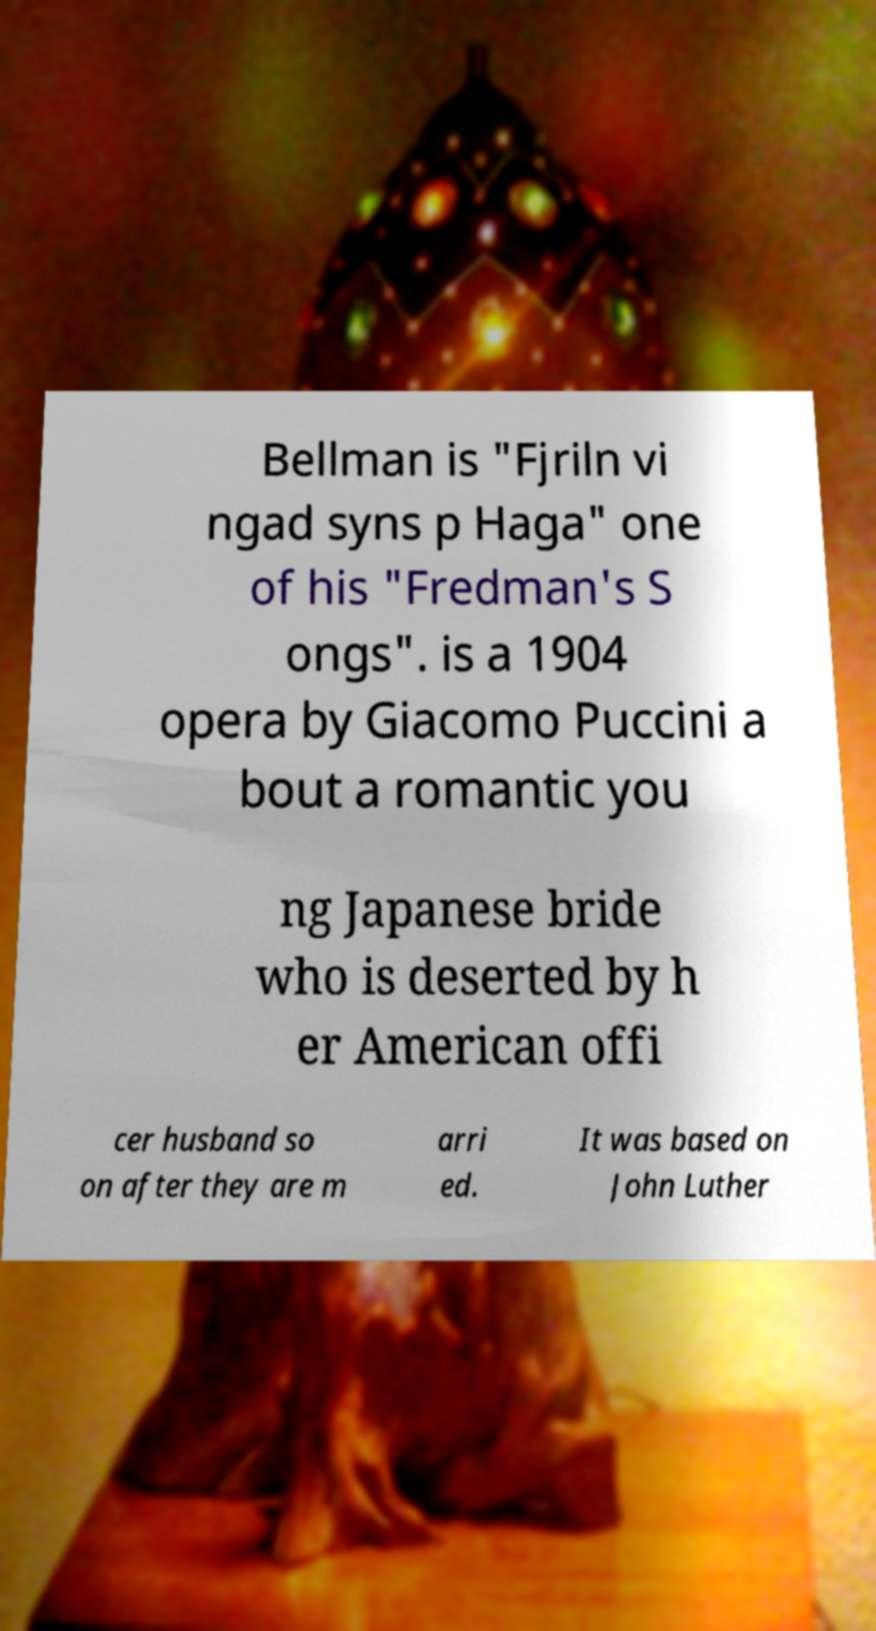There's text embedded in this image that I need extracted. Can you transcribe it verbatim? Bellman is "Fjriln vi ngad syns p Haga" one of his "Fredman's S ongs". is a 1904 opera by Giacomo Puccini a bout a romantic you ng Japanese bride who is deserted by h er American offi cer husband so on after they are m arri ed. It was based on John Luther 